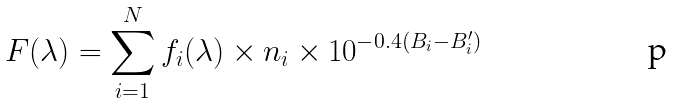<formula> <loc_0><loc_0><loc_500><loc_500>F ( \lambda ) = \sum _ { i = 1 } ^ { N } f _ { i } ( \lambda ) \times n _ { i } \times 1 0 ^ { - 0 . 4 ( B _ { i } - B ^ { \prime } _ { i } ) }</formula> 